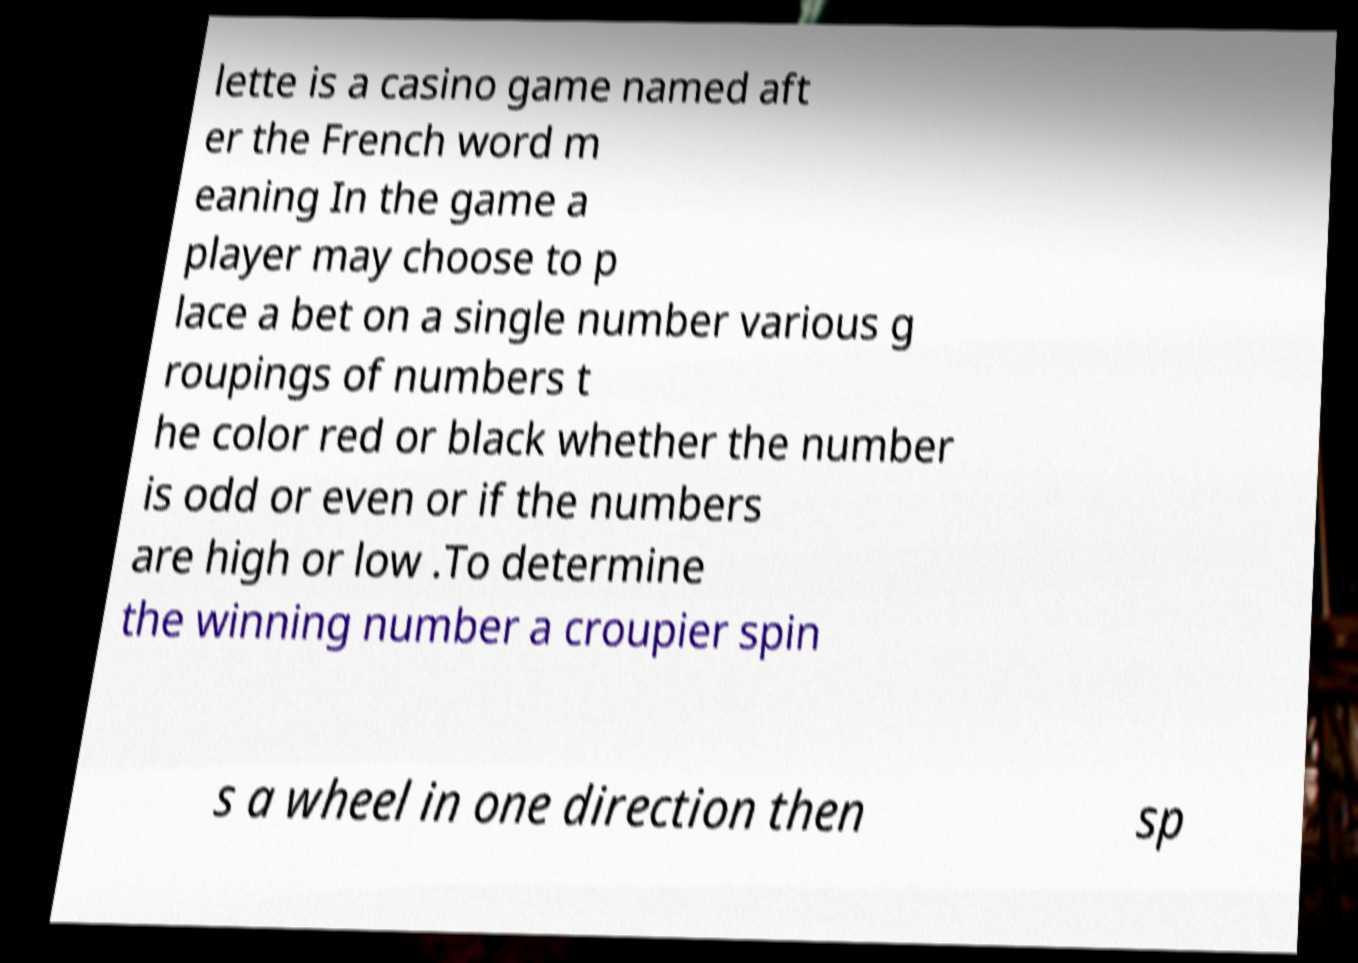Could you assist in decoding the text presented in this image and type it out clearly? lette is a casino game named aft er the French word m eaning In the game a player may choose to p lace a bet on a single number various g roupings of numbers t he color red or black whether the number is odd or even or if the numbers are high or low .To determine the winning number a croupier spin s a wheel in one direction then sp 